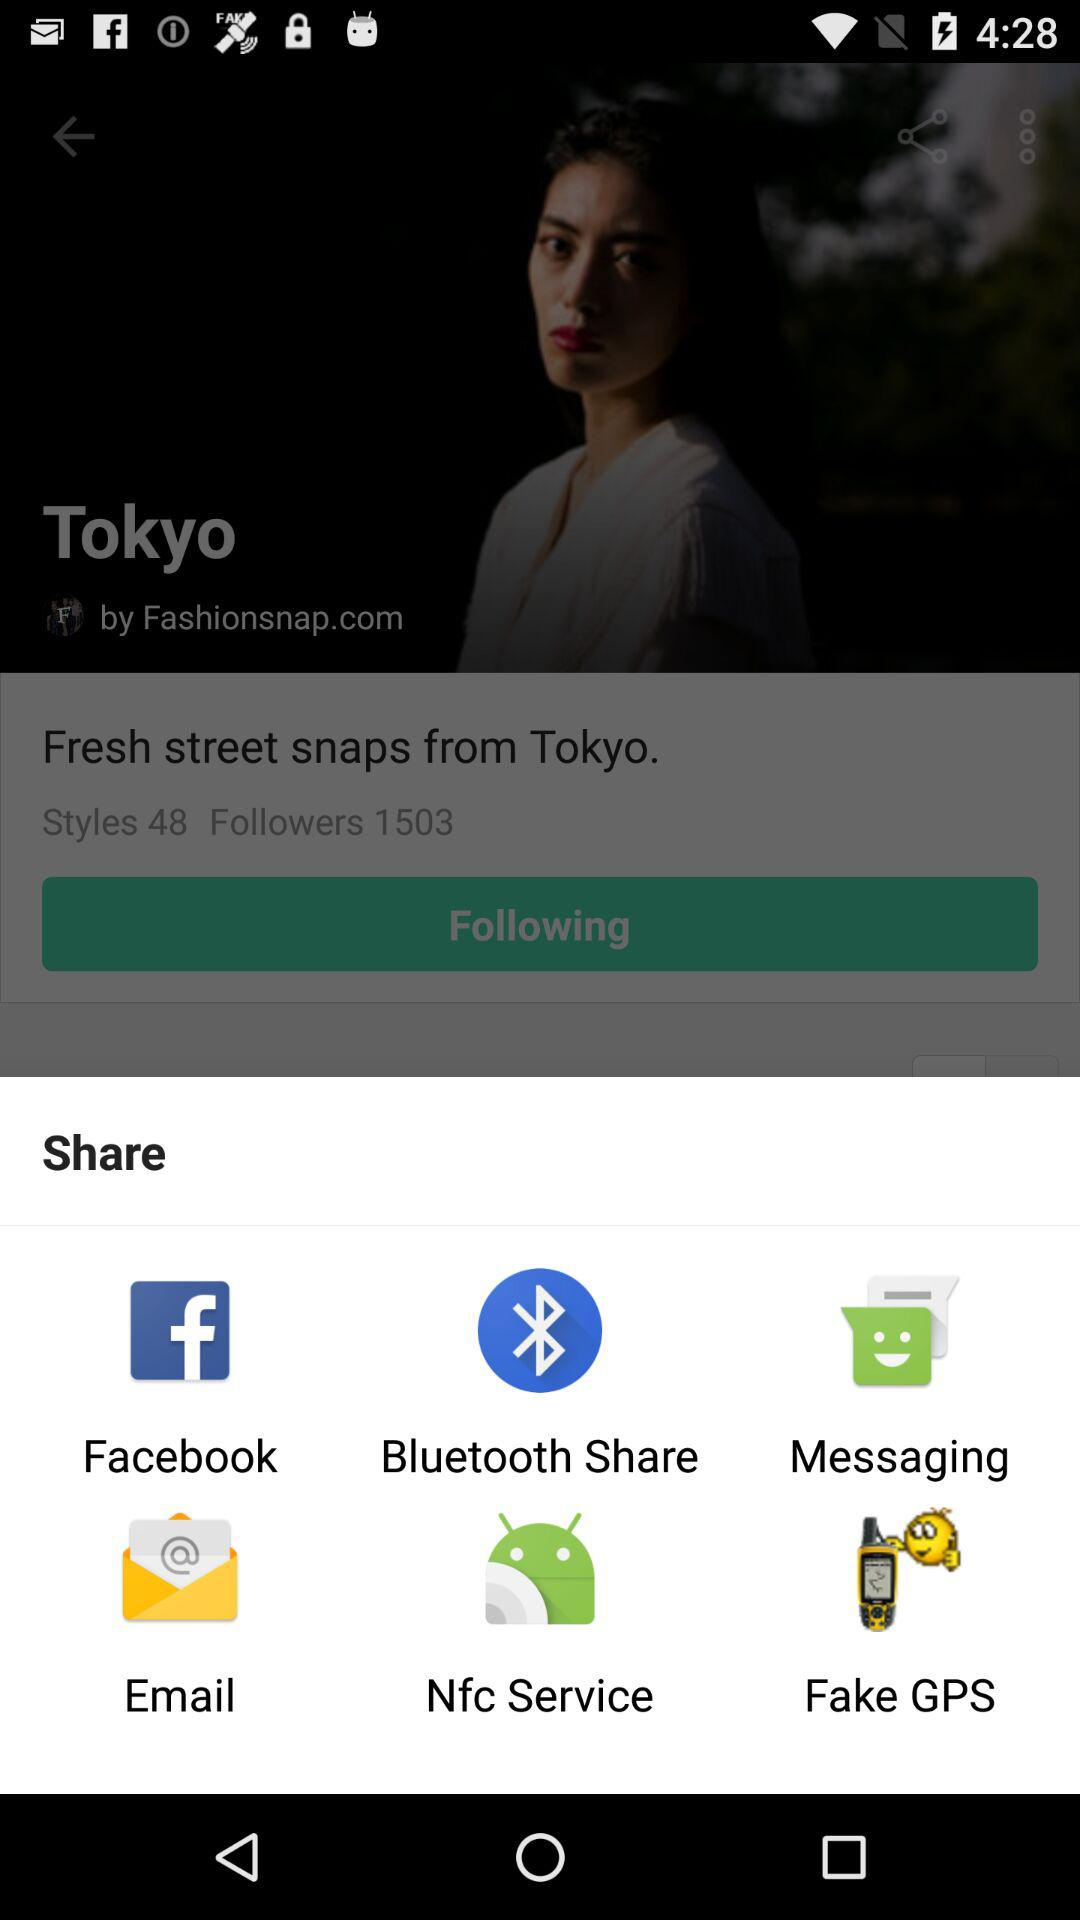Which application can I use to share? You can use "Facebook", "Bluetooth Share", "Messaging", "Email", "Nfc Service" and "Fake GPS" to share. 